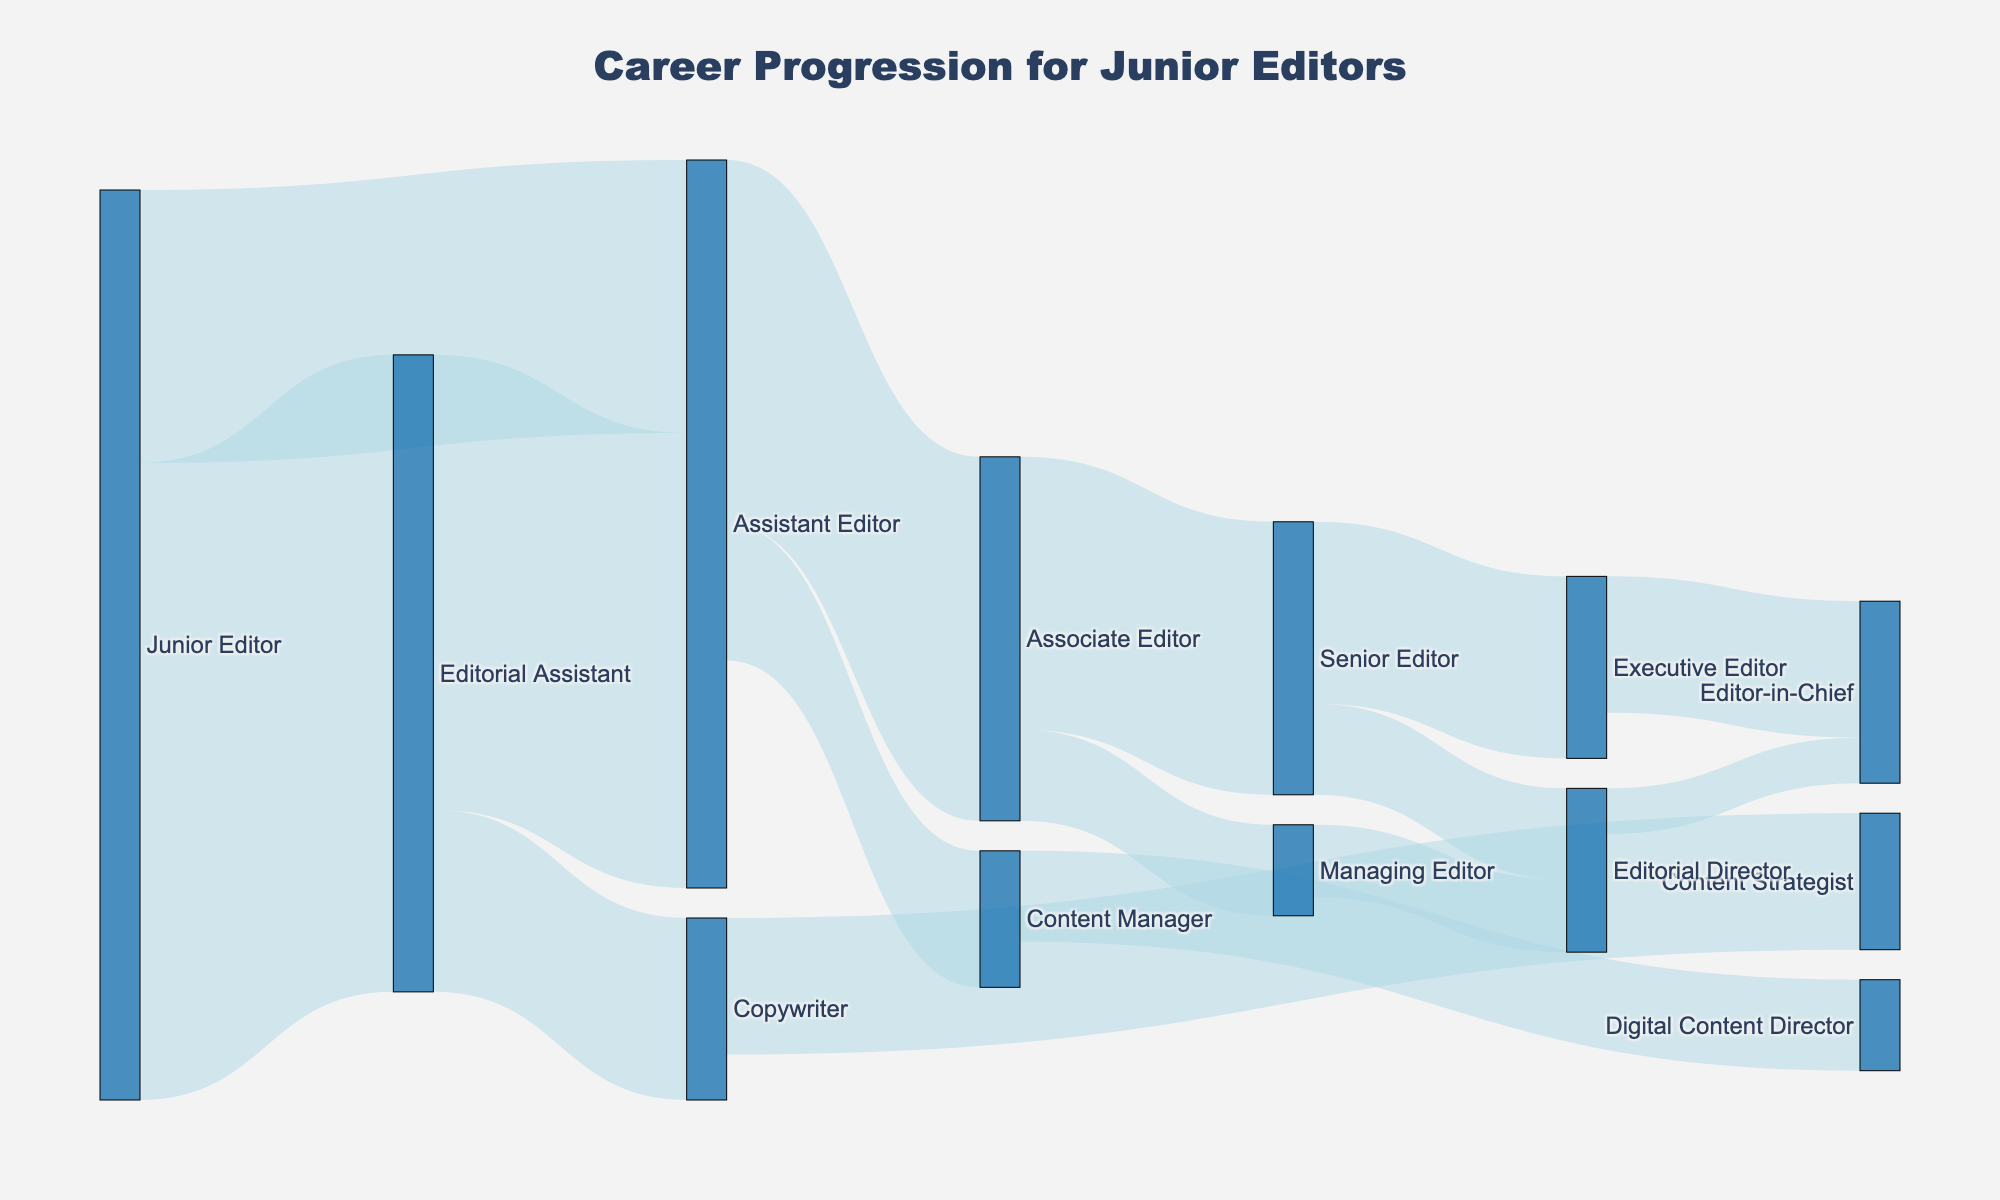What is the title of the Sankey diagram? The title of a chart is usually displayed at the top and helps to quickly understand the main topic that the chart is showing. Here, the title indicates the subject of the chart.
Answer: Career Progression for Junior Editors How many possible career paths can a Junior Editor advance to directly? By identifying the number of direct targets from Junior Editor, you can determine how many positions a Junior Editor can move to next.
Answer: 2 Which role has the highest value transitioning from Editorial Assistant? To determine which role received the highest value from Editorial Assistant, you need to compare the listed values for transitions originating from Editorial Assistant.
Answer: Assistant Editor What is the combined value of transitions from Assistant Editor to other roles? Calculate the total value by summing all the values of transitions from Assistant Editor to its target roles. 40 (to Associate Editor) + 15 (to Content Manager) = 55.
Answer: 55 Is there a role that connects to both Editorial Director and Editor-in-Chief? Look for any roles that appear as a source to both Editorial Director and Editor-in-Chief, based on the linking lines in the Sankey diagram.
Answer: Senior Editor Between Associate Editor and Content Manager, which has more roles they can progress to? Count the number of arrows originating from both Associate Editor and Content Manager and compare the counts. Associate Editor has 2 (Senior Editor and Managing Editor), while Content Manager has 1 (Digital Content Director).
Answer: Associate Editor What is the value of transitions moving into Editor-in-Chief from all roles combined? Add up all the values of the flows that end at Editor-in-Chief: 15 (from Executive Editor) + 5 (from Editorial Director).
Answer: 20 What are the possible next positions after reaching the Senior Editor role? Look for all target roles connected from Senior Editor. This step involves understanding which positions Senior Editor transitions into.
Answer: Executive Editor and Editorial Director Which starting role has the most varied career progression options? Identify the role with the most unique outgoing paths by counting targets for each source role and comparing.
Answer: Junior Editor What is the smallest value of transition between any two roles in the diagram? Scan through the 'value' column to identify the smallest value, considering both the start and end of these transitions.
Answer: 5 